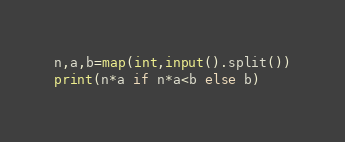<code> <loc_0><loc_0><loc_500><loc_500><_Python_>n,a,b=map(int,input().split())
print(n*a if n*a<b else b)</code> 